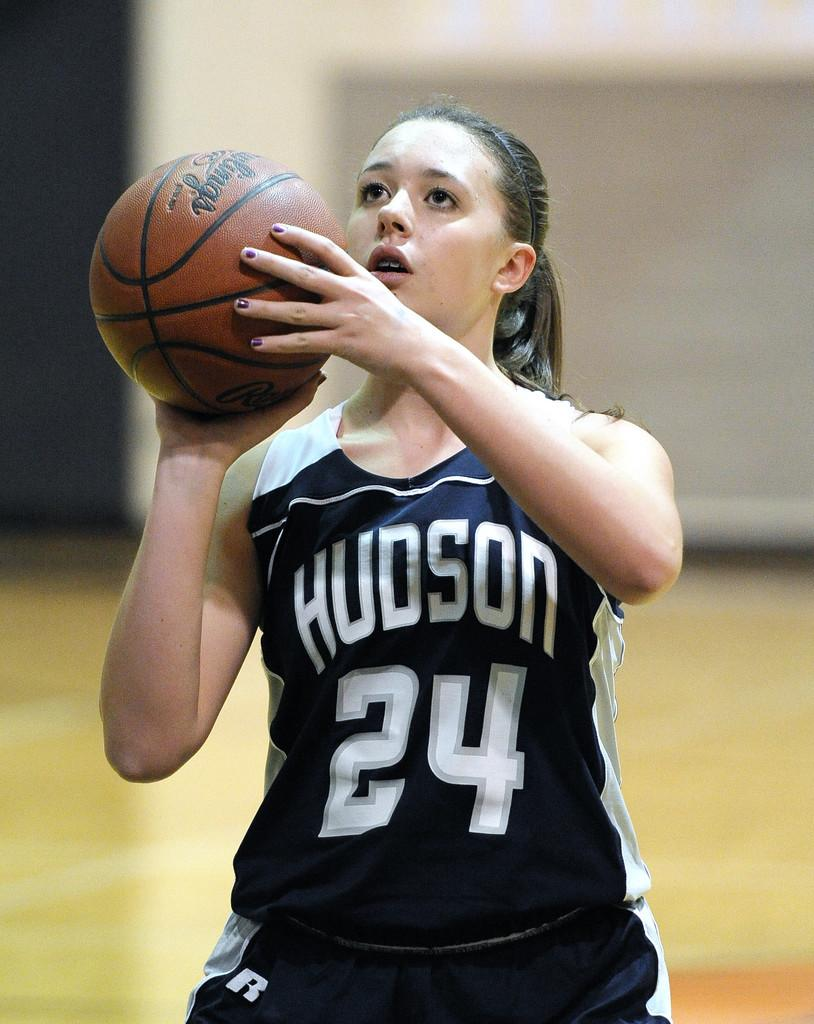<image>
Share a concise interpretation of the image provided. A woman basketball player from Hudson, #24, prepares to shoot the ball. 